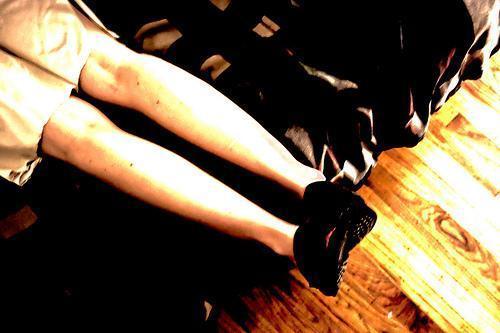How many legs are seen?
Give a very brief answer. 2. How many people are shown?
Give a very brief answer. 1. 